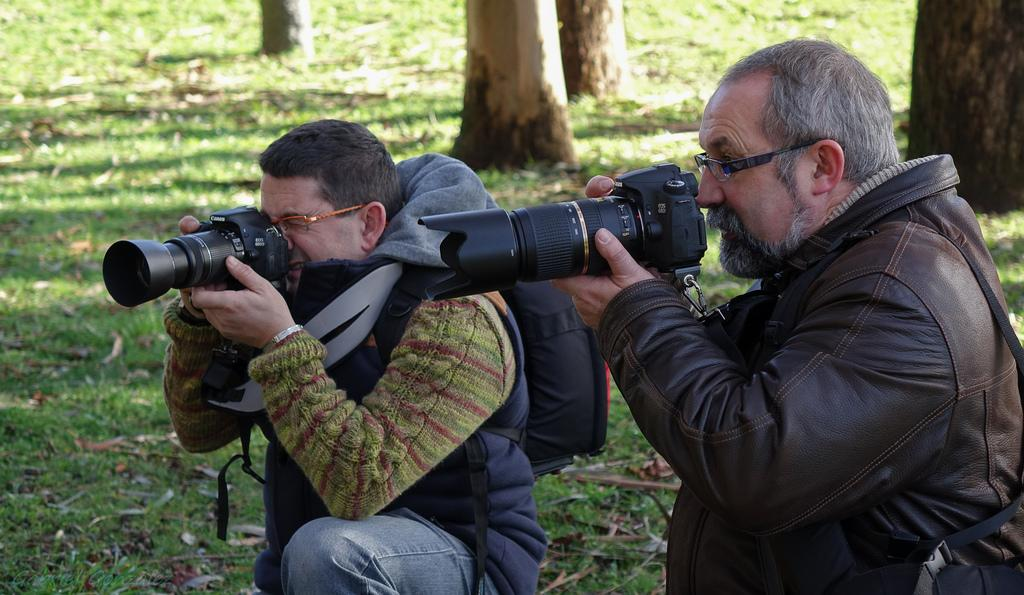What is the primary feature of the land in the image? The land is covered with grass. How many people are present in the image? There are two people in the image. What are the people holding in their hands? The people are holding cameras. What type of clothing are the people wearing? The people are wearing jackets. What flavor of eggs can be seen in the image? There are no eggs present in the image. 